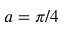Convert formula to latex. <formula><loc_0><loc_0><loc_500><loc_500>a = \pi / 4</formula> 